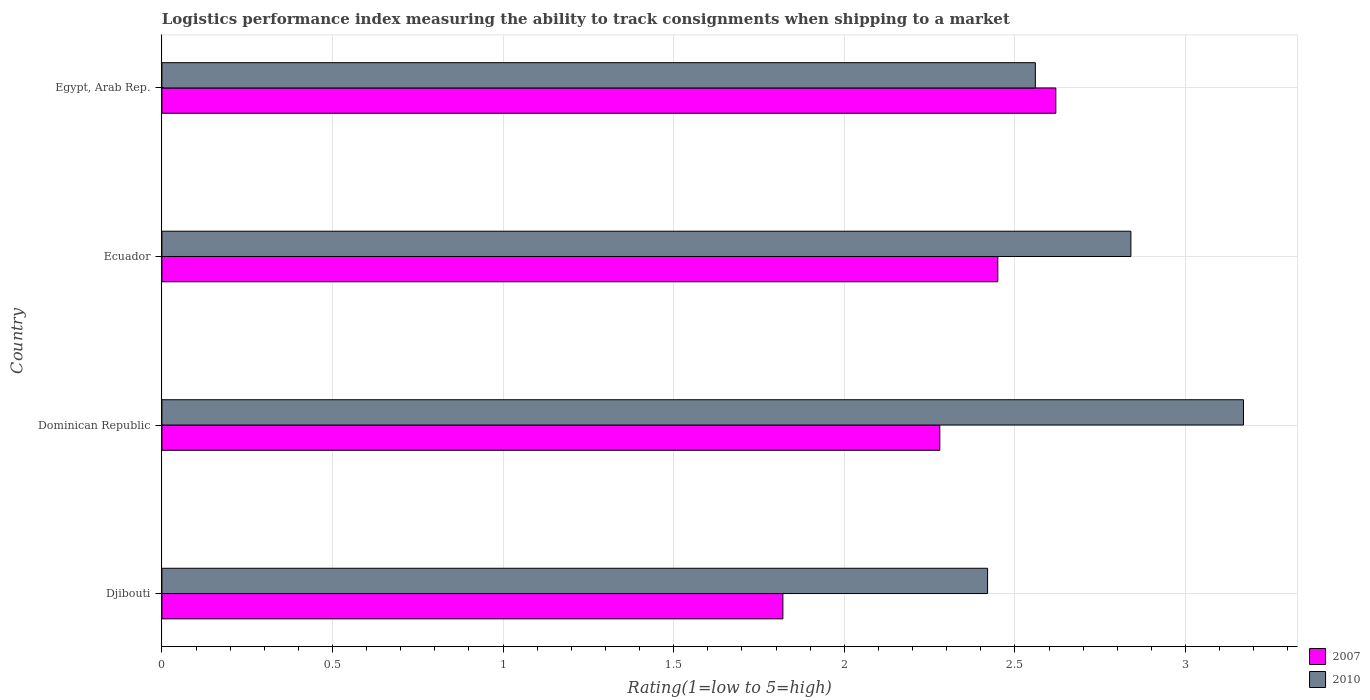How many groups of bars are there?
Your response must be concise. 4. Are the number of bars on each tick of the Y-axis equal?
Keep it short and to the point. Yes. What is the label of the 1st group of bars from the top?
Ensure brevity in your answer.  Egypt, Arab Rep. In how many cases, is the number of bars for a given country not equal to the number of legend labels?
Give a very brief answer. 0. What is the Logistic performance index in 2010 in Ecuador?
Keep it short and to the point. 2.84. Across all countries, what is the maximum Logistic performance index in 2010?
Make the answer very short. 3.17. Across all countries, what is the minimum Logistic performance index in 2007?
Provide a short and direct response. 1.82. In which country was the Logistic performance index in 2007 maximum?
Your answer should be very brief. Egypt, Arab Rep. In which country was the Logistic performance index in 2010 minimum?
Ensure brevity in your answer.  Djibouti. What is the total Logistic performance index in 2007 in the graph?
Ensure brevity in your answer.  9.17. What is the difference between the Logistic performance index in 2007 in Ecuador and that in Egypt, Arab Rep.?
Provide a succinct answer. -0.17. What is the difference between the Logistic performance index in 2007 in Djibouti and the Logistic performance index in 2010 in Dominican Republic?
Offer a terse response. -1.35. What is the average Logistic performance index in 2010 per country?
Provide a succinct answer. 2.75. What is the difference between the Logistic performance index in 2010 and Logistic performance index in 2007 in Dominican Republic?
Keep it short and to the point. 0.89. In how many countries, is the Logistic performance index in 2007 greater than 1.9 ?
Ensure brevity in your answer.  3. What is the ratio of the Logistic performance index in 2010 in Dominican Republic to that in Egypt, Arab Rep.?
Make the answer very short. 1.24. Is the Logistic performance index in 2010 in Djibouti less than that in Egypt, Arab Rep.?
Provide a short and direct response. Yes. Is the difference between the Logistic performance index in 2010 in Ecuador and Egypt, Arab Rep. greater than the difference between the Logistic performance index in 2007 in Ecuador and Egypt, Arab Rep.?
Ensure brevity in your answer.  Yes. What is the difference between the highest and the second highest Logistic performance index in 2007?
Your answer should be compact. 0.17. What is the difference between the highest and the lowest Logistic performance index in 2007?
Your answer should be compact. 0.8. What does the 2nd bar from the bottom in Egypt, Arab Rep. represents?
Give a very brief answer. 2010. Are all the bars in the graph horizontal?
Your answer should be compact. Yes. What is the difference between two consecutive major ticks on the X-axis?
Offer a terse response. 0.5. Does the graph contain grids?
Provide a short and direct response. Yes. How many legend labels are there?
Offer a terse response. 2. How are the legend labels stacked?
Your answer should be very brief. Vertical. What is the title of the graph?
Offer a very short reply. Logistics performance index measuring the ability to track consignments when shipping to a market. What is the label or title of the X-axis?
Make the answer very short. Rating(1=low to 5=high). What is the Rating(1=low to 5=high) in 2007 in Djibouti?
Offer a terse response. 1.82. What is the Rating(1=low to 5=high) in 2010 in Djibouti?
Keep it short and to the point. 2.42. What is the Rating(1=low to 5=high) of 2007 in Dominican Republic?
Offer a terse response. 2.28. What is the Rating(1=low to 5=high) in 2010 in Dominican Republic?
Offer a terse response. 3.17. What is the Rating(1=low to 5=high) in 2007 in Ecuador?
Offer a terse response. 2.45. What is the Rating(1=low to 5=high) in 2010 in Ecuador?
Offer a terse response. 2.84. What is the Rating(1=low to 5=high) of 2007 in Egypt, Arab Rep.?
Keep it short and to the point. 2.62. What is the Rating(1=low to 5=high) of 2010 in Egypt, Arab Rep.?
Provide a short and direct response. 2.56. Across all countries, what is the maximum Rating(1=low to 5=high) of 2007?
Offer a very short reply. 2.62. Across all countries, what is the maximum Rating(1=low to 5=high) in 2010?
Ensure brevity in your answer.  3.17. Across all countries, what is the minimum Rating(1=low to 5=high) of 2007?
Keep it short and to the point. 1.82. Across all countries, what is the minimum Rating(1=low to 5=high) in 2010?
Offer a terse response. 2.42. What is the total Rating(1=low to 5=high) in 2007 in the graph?
Ensure brevity in your answer.  9.17. What is the total Rating(1=low to 5=high) in 2010 in the graph?
Ensure brevity in your answer.  10.99. What is the difference between the Rating(1=low to 5=high) of 2007 in Djibouti and that in Dominican Republic?
Offer a terse response. -0.46. What is the difference between the Rating(1=low to 5=high) of 2010 in Djibouti and that in Dominican Republic?
Make the answer very short. -0.75. What is the difference between the Rating(1=low to 5=high) in 2007 in Djibouti and that in Ecuador?
Offer a terse response. -0.63. What is the difference between the Rating(1=low to 5=high) of 2010 in Djibouti and that in Ecuador?
Your response must be concise. -0.42. What is the difference between the Rating(1=low to 5=high) in 2007 in Djibouti and that in Egypt, Arab Rep.?
Keep it short and to the point. -0.8. What is the difference between the Rating(1=low to 5=high) in 2010 in Djibouti and that in Egypt, Arab Rep.?
Offer a very short reply. -0.14. What is the difference between the Rating(1=low to 5=high) of 2007 in Dominican Republic and that in Ecuador?
Ensure brevity in your answer.  -0.17. What is the difference between the Rating(1=low to 5=high) of 2010 in Dominican Republic and that in Ecuador?
Give a very brief answer. 0.33. What is the difference between the Rating(1=low to 5=high) of 2007 in Dominican Republic and that in Egypt, Arab Rep.?
Your answer should be very brief. -0.34. What is the difference between the Rating(1=low to 5=high) in 2010 in Dominican Republic and that in Egypt, Arab Rep.?
Offer a very short reply. 0.61. What is the difference between the Rating(1=low to 5=high) in 2007 in Ecuador and that in Egypt, Arab Rep.?
Offer a very short reply. -0.17. What is the difference between the Rating(1=low to 5=high) of 2010 in Ecuador and that in Egypt, Arab Rep.?
Your response must be concise. 0.28. What is the difference between the Rating(1=low to 5=high) of 2007 in Djibouti and the Rating(1=low to 5=high) of 2010 in Dominican Republic?
Provide a short and direct response. -1.35. What is the difference between the Rating(1=low to 5=high) in 2007 in Djibouti and the Rating(1=low to 5=high) in 2010 in Ecuador?
Make the answer very short. -1.02. What is the difference between the Rating(1=low to 5=high) in 2007 in Djibouti and the Rating(1=low to 5=high) in 2010 in Egypt, Arab Rep.?
Offer a terse response. -0.74. What is the difference between the Rating(1=low to 5=high) in 2007 in Dominican Republic and the Rating(1=low to 5=high) in 2010 in Ecuador?
Ensure brevity in your answer.  -0.56. What is the difference between the Rating(1=low to 5=high) in 2007 in Dominican Republic and the Rating(1=low to 5=high) in 2010 in Egypt, Arab Rep.?
Keep it short and to the point. -0.28. What is the difference between the Rating(1=low to 5=high) of 2007 in Ecuador and the Rating(1=low to 5=high) of 2010 in Egypt, Arab Rep.?
Your answer should be very brief. -0.11. What is the average Rating(1=low to 5=high) of 2007 per country?
Provide a short and direct response. 2.29. What is the average Rating(1=low to 5=high) of 2010 per country?
Make the answer very short. 2.75. What is the difference between the Rating(1=low to 5=high) in 2007 and Rating(1=low to 5=high) in 2010 in Dominican Republic?
Your answer should be very brief. -0.89. What is the difference between the Rating(1=low to 5=high) of 2007 and Rating(1=low to 5=high) of 2010 in Ecuador?
Your answer should be compact. -0.39. What is the ratio of the Rating(1=low to 5=high) of 2007 in Djibouti to that in Dominican Republic?
Give a very brief answer. 0.8. What is the ratio of the Rating(1=low to 5=high) in 2010 in Djibouti to that in Dominican Republic?
Provide a short and direct response. 0.76. What is the ratio of the Rating(1=low to 5=high) of 2007 in Djibouti to that in Ecuador?
Your response must be concise. 0.74. What is the ratio of the Rating(1=low to 5=high) of 2010 in Djibouti to that in Ecuador?
Give a very brief answer. 0.85. What is the ratio of the Rating(1=low to 5=high) of 2007 in Djibouti to that in Egypt, Arab Rep.?
Your answer should be very brief. 0.69. What is the ratio of the Rating(1=low to 5=high) in 2010 in Djibouti to that in Egypt, Arab Rep.?
Give a very brief answer. 0.95. What is the ratio of the Rating(1=low to 5=high) in 2007 in Dominican Republic to that in Ecuador?
Ensure brevity in your answer.  0.93. What is the ratio of the Rating(1=low to 5=high) in 2010 in Dominican Republic to that in Ecuador?
Provide a short and direct response. 1.12. What is the ratio of the Rating(1=low to 5=high) in 2007 in Dominican Republic to that in Egypt, Arab Rep.?
Offer a terse response. 0.87. What is the ratio of the Rating(1=low to 5=high) of 2010 in Dominican Republic to that in Egypt, Arab Rep.?
Make the answer very short. 1.24. What is the ratio of the Rating(1=low to 5=high) in 2007 in Ecuador to that in Egypt, Arab Rep.?
Your answer should be compact. 0.94. What is the ratio of the Rating(1=low to 5=high) of 2010 in Ecuador to that in Egypt, Arab Rep.?
Your response must be concise. 1.11. What is the difference between the highest and the second highest Rating(1=low to 5=high) of 2007?
Your answer should be compact. 0.17. What is the difference between the highest and the second highest Rating(1=low to 5=high) in 2010?
Give a very brief answer. 0.33. What is the difference between the highest and the lowest Rating(1=low to 5=high) of 2010?
Keep it short and to the point. 0.75. 